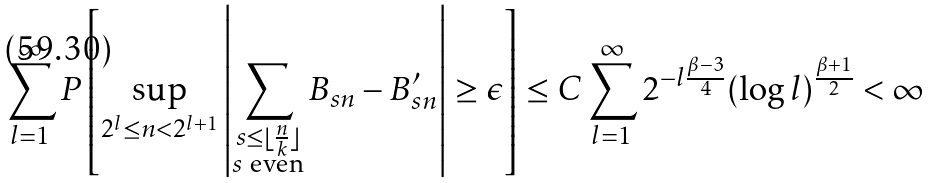<formula> <loc_0><loc_0><loc_500><loc_500>\sum _ { l = 1 } ^ { \infty } P \left [ \sup _ { 2 ^ { l } \leq n < 2 ^ { l + 1 } } \left | \sum _ { \substack { s \leq \lfloor \frac { n } { k } \rfloor \\ s \text { even} } } B _ { s n } - B _ { s n } ^ { \prime } \right | \geq \epsilon \right ] \leq C \sum _ { l = 1 } ^ { \infty } 2 ^ { - l \frac { \beta - 3 } { 4 } } ( \log l ) ^ { \frac { \beta + 1 } { 2 } } < \infty</formula> 